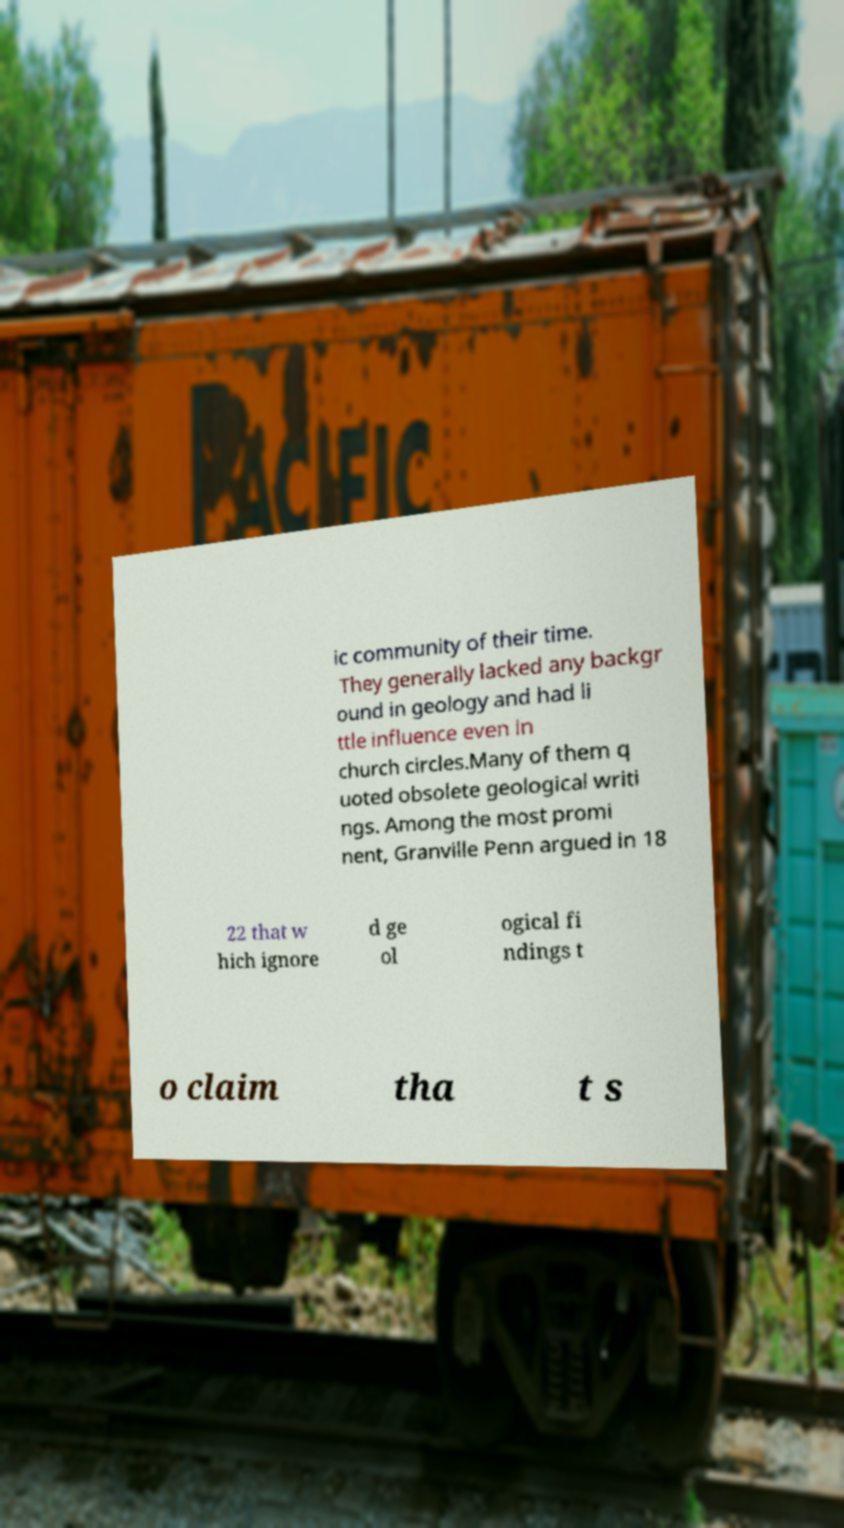Please read and relay the text visible in this image. What does it say? ic community of their time. They generally lacked any backgr ound in geology and had li ttle influence even in church circles.Many of them q uoted obsolete geological writi ngs. Among the most promi nent, Granville Penn argued in 18 22 that w hich ignore d ge ol ogical fi ndings t o claim tha t s 